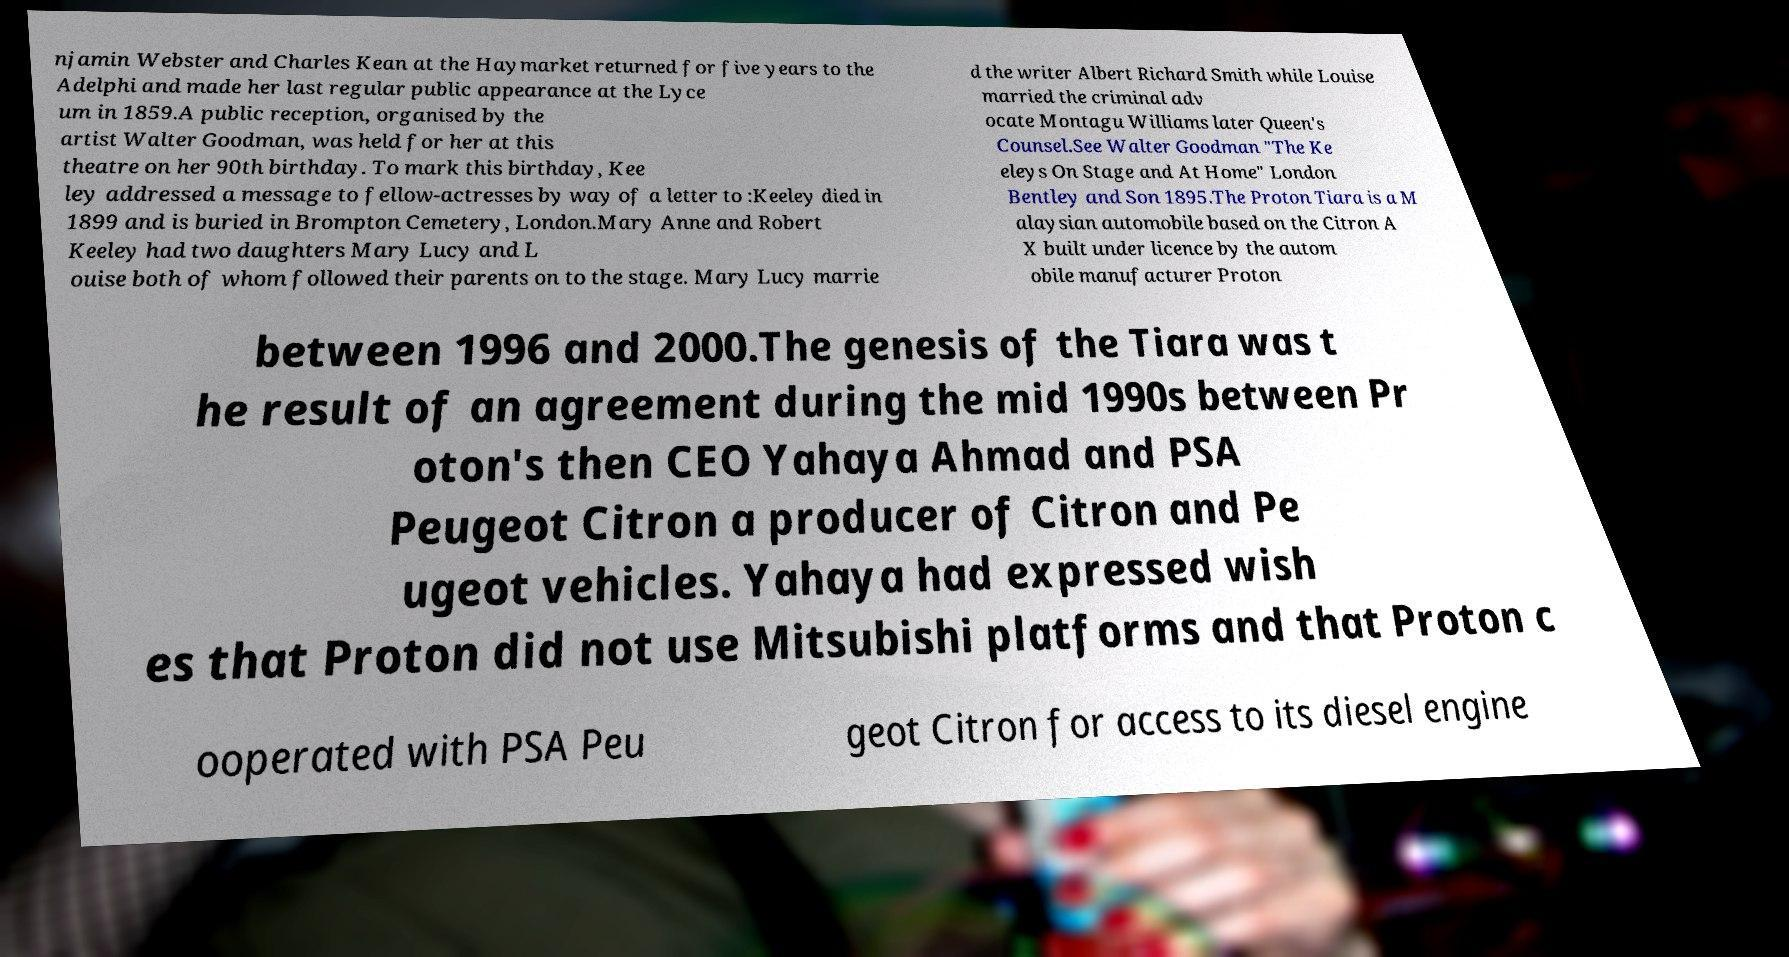Please identify and transcribe the text found in this image. njamin Webster and Charles Kean at the Haymarket returned for five years to the Adelphi and made her last regular public appearance at the Lyce um in 1859.A public reception, organised by the artist Walter Goodman, was held for her at this theatre on her 90th birthday. To mark this birthday, Kee ley addressed a message to fellow-actresses by way of a letter to :Keeley died in 1899 and is buried in Brompton Cemetery, London.Mary Anne and Robert Keeley had two daughters Mary Lucy and L ouise both of whom followed their parents on to the stage. Mary Lucy marrie d the writer Albert Richard Smith while Louise married the criminal adv ocate Montagu Williams later Queen's Counsel.See Walter Goodman "The Ke eleys On Stage and At Home" London Bentley and Son 1895.The Proton Tiara is a M alaysian automobile based on the Citron A X built under licence by the autom obile manufacturer Proton between 1996 and 2000.The genesis of the Tiara was t he result of an agreement during the mid 1990s between Pr oton's then CEO Yahaya Ahmad and PSA Peugeot Citron a producer of Citron and Pe ugeot vehicles. Yahaya had expressed wish es that Proton did not use Mitsubishi platforms and that Proton c ooperated with PSA Peu geot Citron for access to its diesel engine 